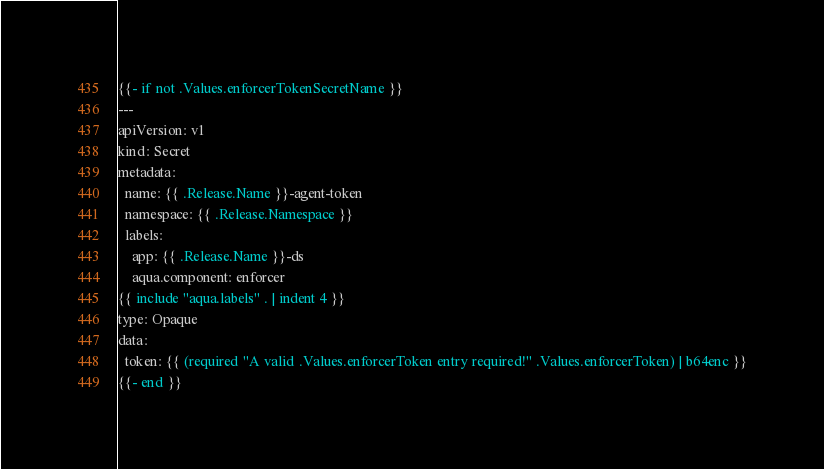Convert code to text. <code><loc_0><loc_0><loc_500><loc_500><_YAML_>{{- if not .Values.enforcerTokenSecretName }}
---
apiVersion: v1
kind: Secret
metadata:
  name: {{ .Release.Name }}-agent-token
  namespace: {{ .Release.Namespace }}
  labels:
    app: {{ .Release.Name }}-ds
    aqua.component: enforcer
{{ include "aqua.labels" . | indent 4 }}
type: Opaque
data:
  token: {{ (required "A valid .Values.enforcerToken entry required!" .Values.enforcerToken) | b64enc }}
{{- end }}</code> 